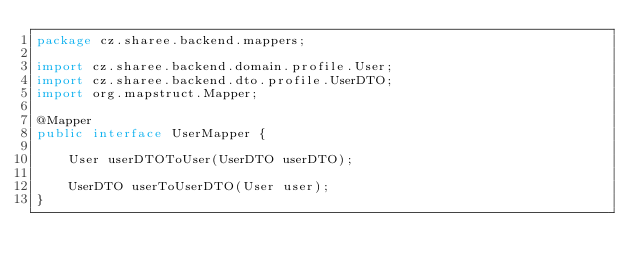<code> <loc_0><loc_0><loc_500><loc_500><_Java_>package cz.sharee.backend.mappers;

import cz.sharee.backend.domain.profile.User;
import cz.sharee.backend.dto.profile.UserDTO;
import org.mapstruct.Mapper;

@Mapper
public interface UserMapper {

    User userDTOToUser(UserDTO userDTO);

    UserDTO userToUserDTO(User user);
}
</code> 